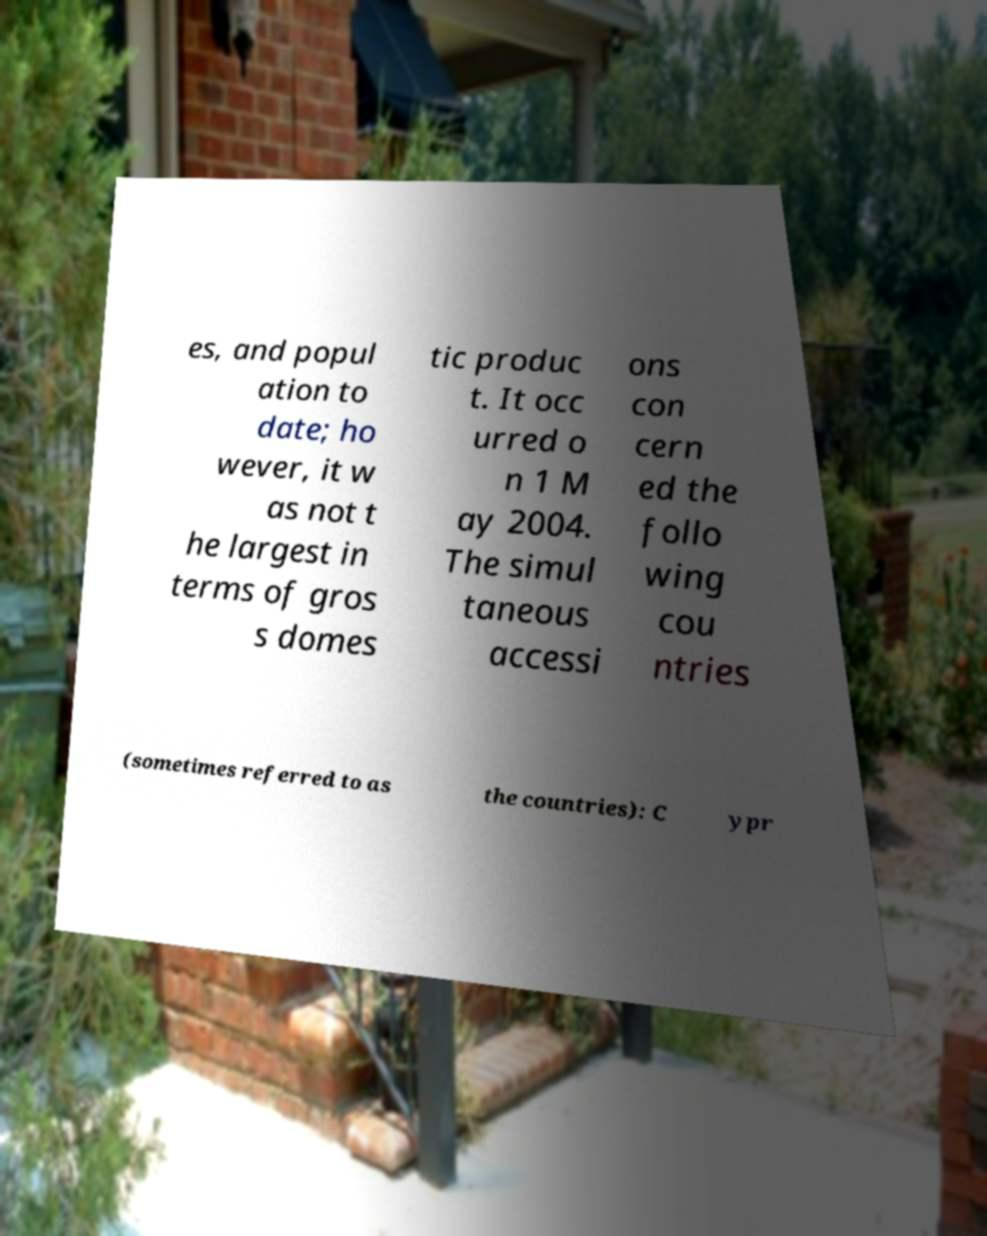For documentation purposes, I need the text within this image transcribed. Could you provide that? es, and popul ation to date; ho wever, it w as not t he largest in terms of gros s domes tic produc t. It occ urred o n 1 M ay 2004. The simul taneous accessi ons con cern ed the follo wing cou ntries (sometimes referred to as the countries): C ypr 